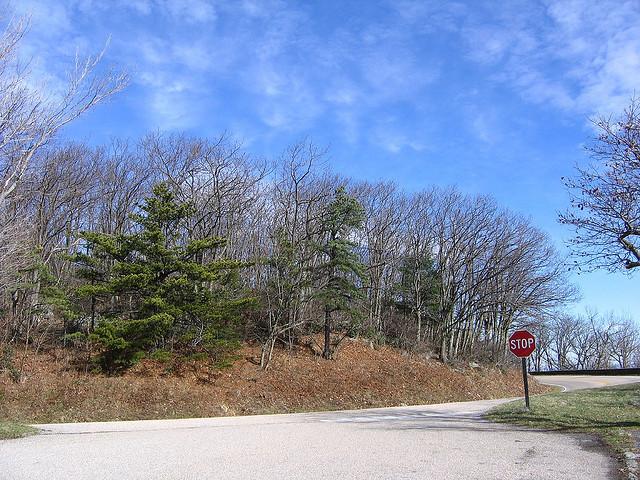What is the name of the photographic effect applied to this image?
Quick response, please. Contrast. Where is the photographer standing?
Concise answer only. Side of road. What kind of clouds are in the picture?
Concise answer only. White. What color is the grass?
Short answer required. Green. What kind of forest is ahead?
Write a very short answer. National. What is the object in this picture?
Concise answer only. Stop sign. What does the street sign say?
Give a very brief answer. Stop. What does the sign say?
Quick response, please. Stop. What kind of weather is this?
Answer briefly. Sunny. Is it Shady?
Quick response, please. No. How many trees are there?
Give a very brief answer. 15. Is the path paved?
Quick response, please. Yes. 